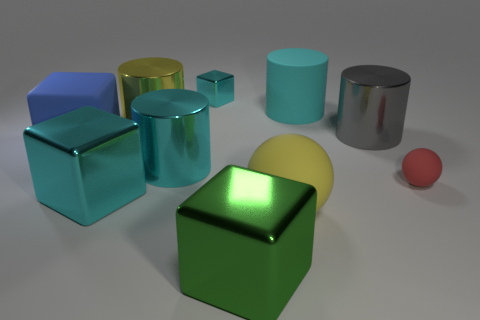What number of things are either big purple cylinders or things right of the tiny block?
Your answer should be very brief. 5. What is the material of the red thing?
Ensure brevity in your answer.  Rubber. What is the material of the other blue object that is the same shape as the small metal object?
Provide a short and direct response. Rubber. There is a large metallic cylinder that is in front of the big blue thing to the left of the large yellow metallic thing; what color is it?
Give a very brief answer. Cyan. How many rubber objects are either tiny cyan blocks or cyan cylinders?
Provide a succinct answer. 1. Are the big blue block and the gray cylinder made of the same material?
Make the answer very short. No. There is a cylinder right of the big matte object that is behind the yellow metal cylinder; what is it made of?
Give a very brief answer. Metal. How many tiny things are cylinders or yellow spheres?
Keep it short and to the point. 0. What is the size of the rubber cube?
Make the answer very short. Large. Is the number of cylinders that are in front of the yellow cylinder greater than the number of big yellow shiny things?
Provide a succinct answer. Yes. 